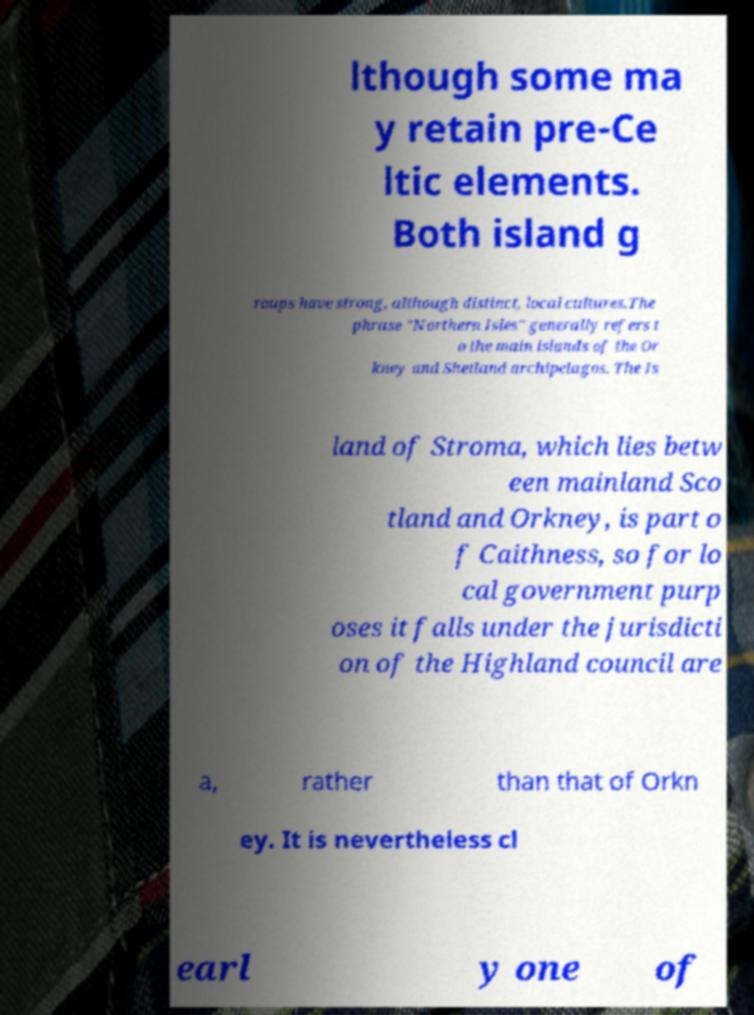Can you accurately transcribe the text from the provided image for me? lthough some ma y retain pre-Ce ltic elements. Both island g roups have strong, although distinct, local cultures.The phrase "Northern Isles" generally refers t o the main islands of the Or kney and Shetland archipelagos. The Is land of Stroma, which lies betw een mainland Sco tland and Orkney, is part o f Caithness, so for lo cal government purp oses it falls under the jurisdicti on of the Highland council are a, rather than that of Orkn ey. It is nevertheless cl earl y one of 